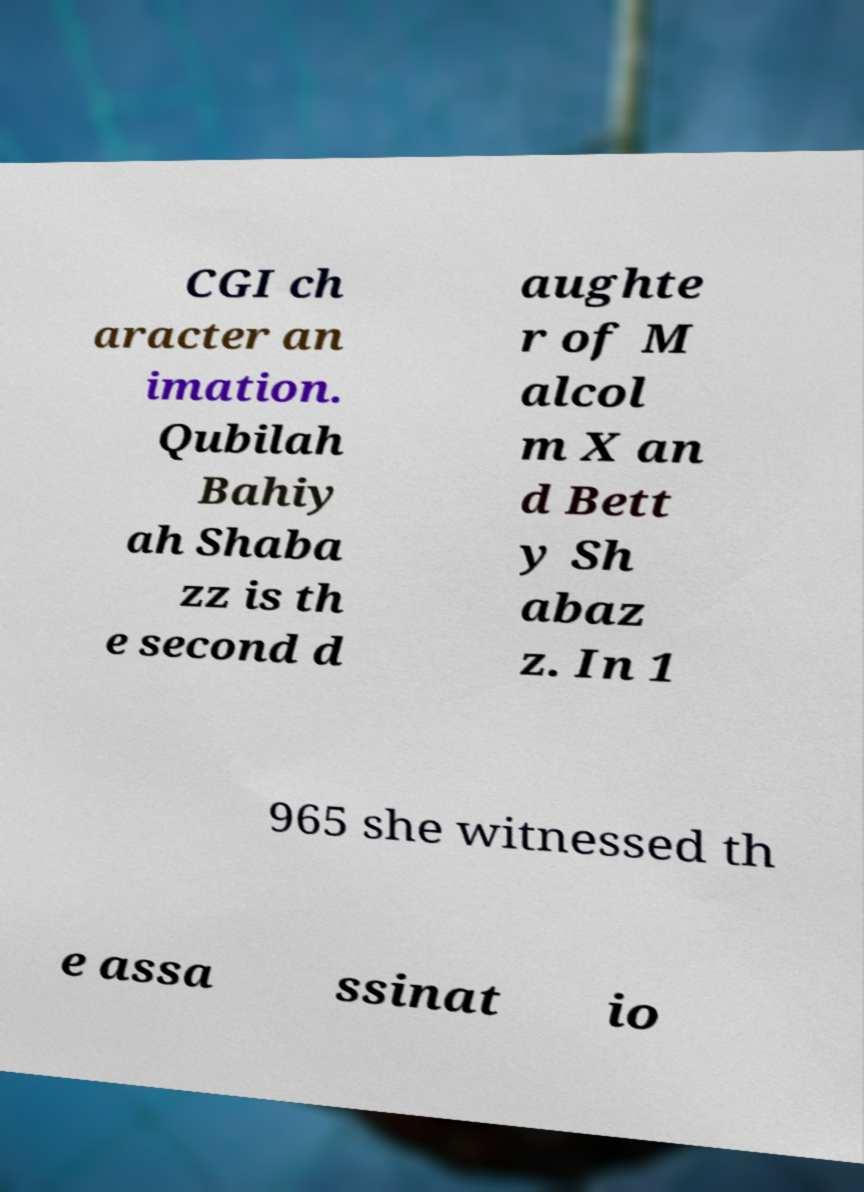I need the written content from this picture converted into text. Can you do that? CGI ch aracter an imation. Qubilah Bahiy ah Shaba zz is th e second d aughte r of M alcol m X an d Bett y Sh abaz z. In 1 965 she witnessed th e assa ssinat io 